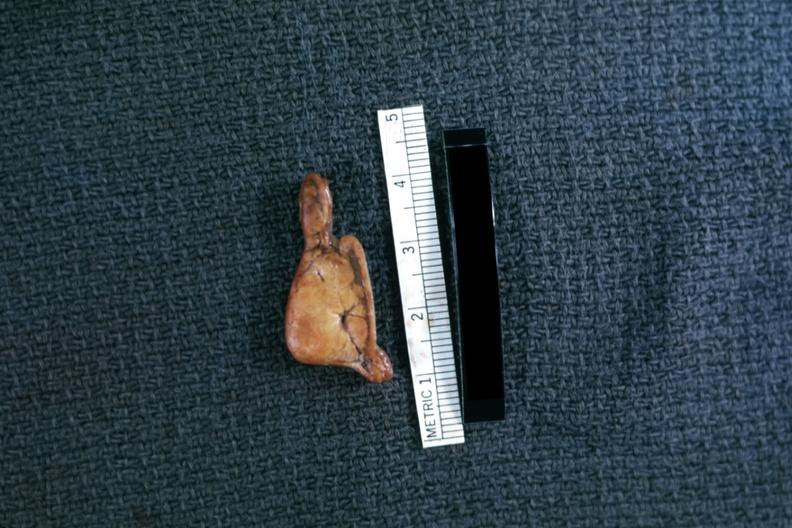s peritoneum present?
Answer the question using a single word or phrase. No 